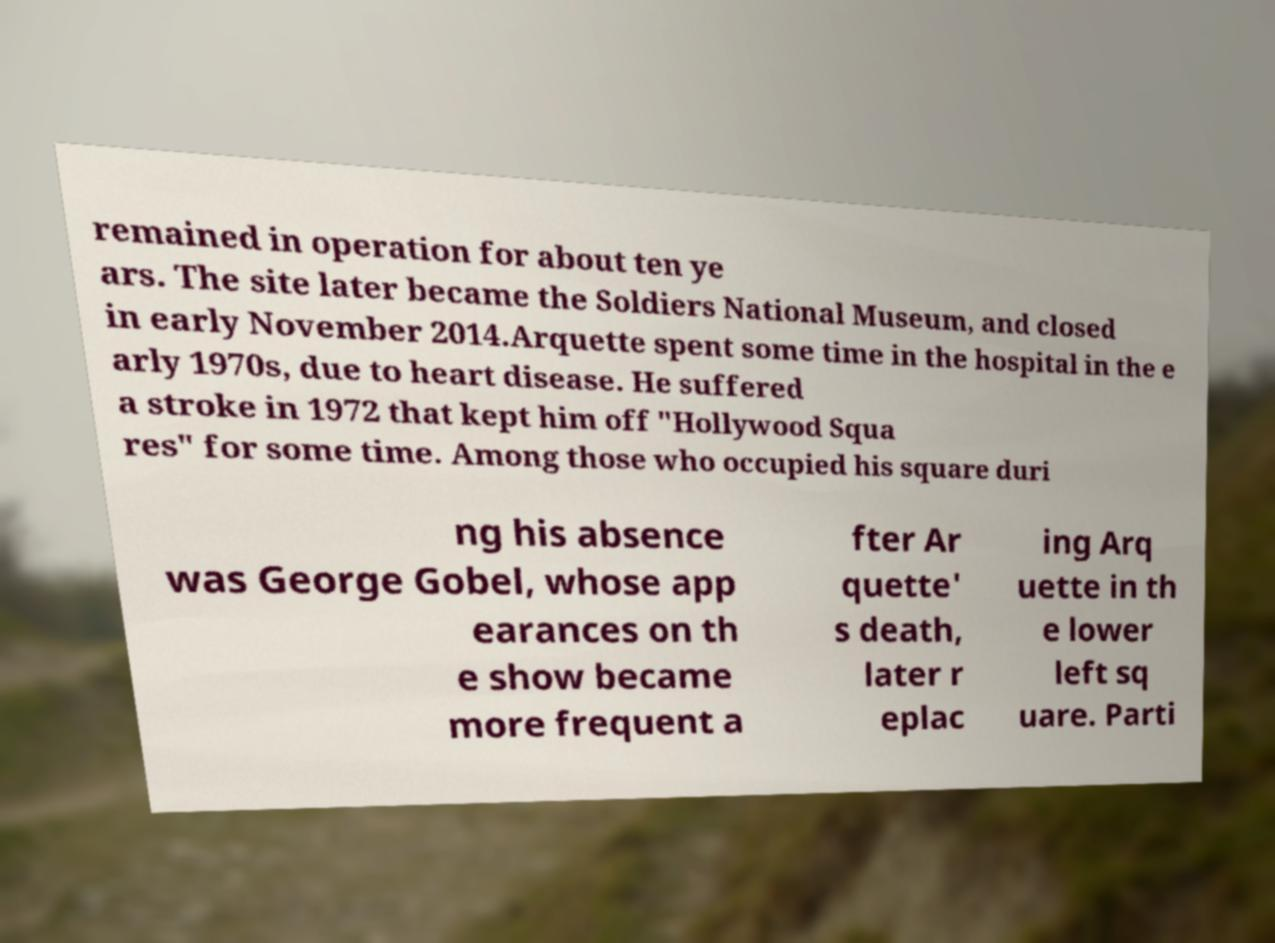Could you extract and type out the text from this image? remained in operation for about ten ye ars. The site later became the Soldiers National Museum, and closed in early November 2014.Arquette spent some time in the hospital in the e arly 1970s, due to heart disease. He suffered a stroke in 1972 that kept him off "Hollywood Squa res" for some time. Among those who occupied his square duri ng his absence was George Gobel, whose app earances on th e show became more frequent a fter Ar quette' s death, later r eplac ing Arq uette in th e lower left sq uare. Parti 